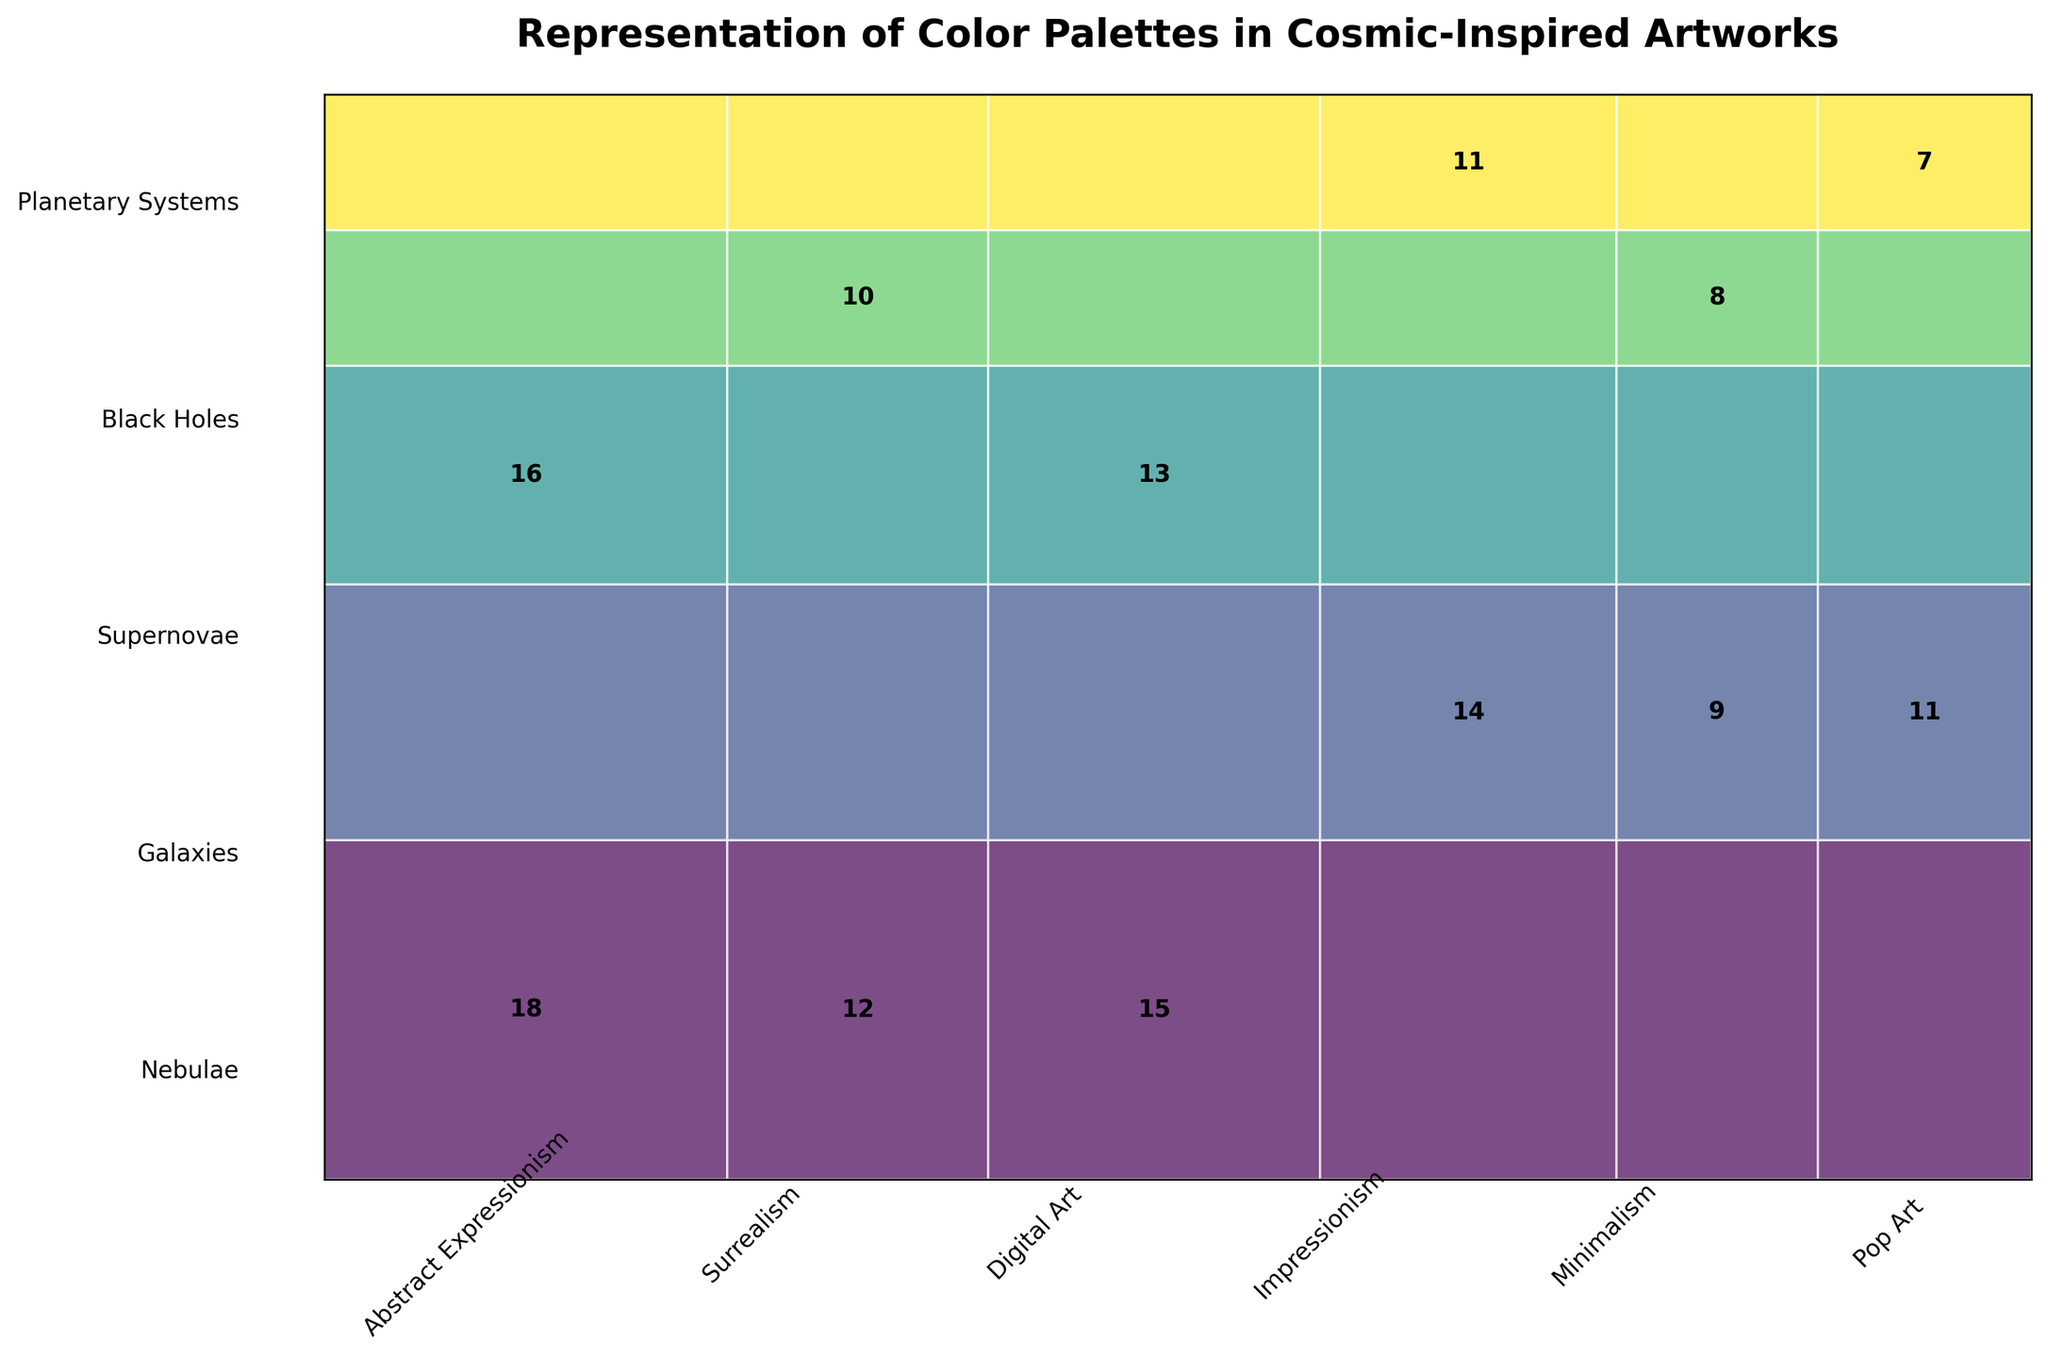What is the title of the mosaic plot? The title is usually found at the top of the plot and serves to describe what the data visualization is about. In this case, it specifies the scope and content of the artwork being analyzed.
Answer: Representation of Color Palettes in Cosmic-Inspired Artworks How many artistic styles are represented in the plot? By looking at the x-axis labels, we can count the different artistic styles listed. Each segment along the x-axis corresponds to a different style.
Answer: 6 Which astronomical phenomenon has the highest total frequency of artworks? To find this, we need to compare the sum of frequencies for each astronomical phenomenon. The height of each color block represents the total frequency for that phenomenon.
Answer: Nebulae Which artistic style has the least frequency in depicting Black Holes? To find this, we look at the widths of the segments under "Black Holes". Each segment within it shows the frequency for a different artistic style.
Answer: Minimalism What is the total frequency of artworks depicting Galaxies? We add up the frequencies for all artistic styles depicting Galaxies. We can see each frequency number inside the rectangles that make up the "Galaxies" row.
Answer: 34 Which color palette is most used in Digital Art depicting cosmic phenomena? By locating the rectangles under "Digital Art" and reading their labels, we identify which color palette is frequently used.
Answer: Vibrant Multicolor Which astronomical phenomenon has the most styles represented? By scanning vertically along the y-axis for each phenomenon, we count how many different artistic styles are represented within each phenomenon category.
Answer: Nebulae Compare the frequency of Pop Art representations between Galaxies and Planetary Systems. Check the "Pop Art" segments within the Galaxies and Planetary Systems rows to compare their widths.
Answer: Pop Art is more frequent for Galaxies (11 vs. 7) What’s the proportion of Surrealism artworks in relation to all artworks? Add up all the frequencies labeled under "Surrealism" and divide by the total sum of all frequencies in the plot. The result is the proportion.
Answer: 22/144 ≈ 0.15 Which phenomenon and artistic style combination has exactly 16 artworks? Identify the rectangle labeled with the frequency '16' and trace it to the respective astronomical phenomenon and artistic style.
Answer: Supernovae, Abstract Expressionism 